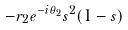Convert formula to latex. <formula><loc_0><loc_0><loc_500><loc_500>- r _ { 2 } e ^ { - i \theta _ { 2 } } s ^ { 2 } ( 1 - s )</formula> 